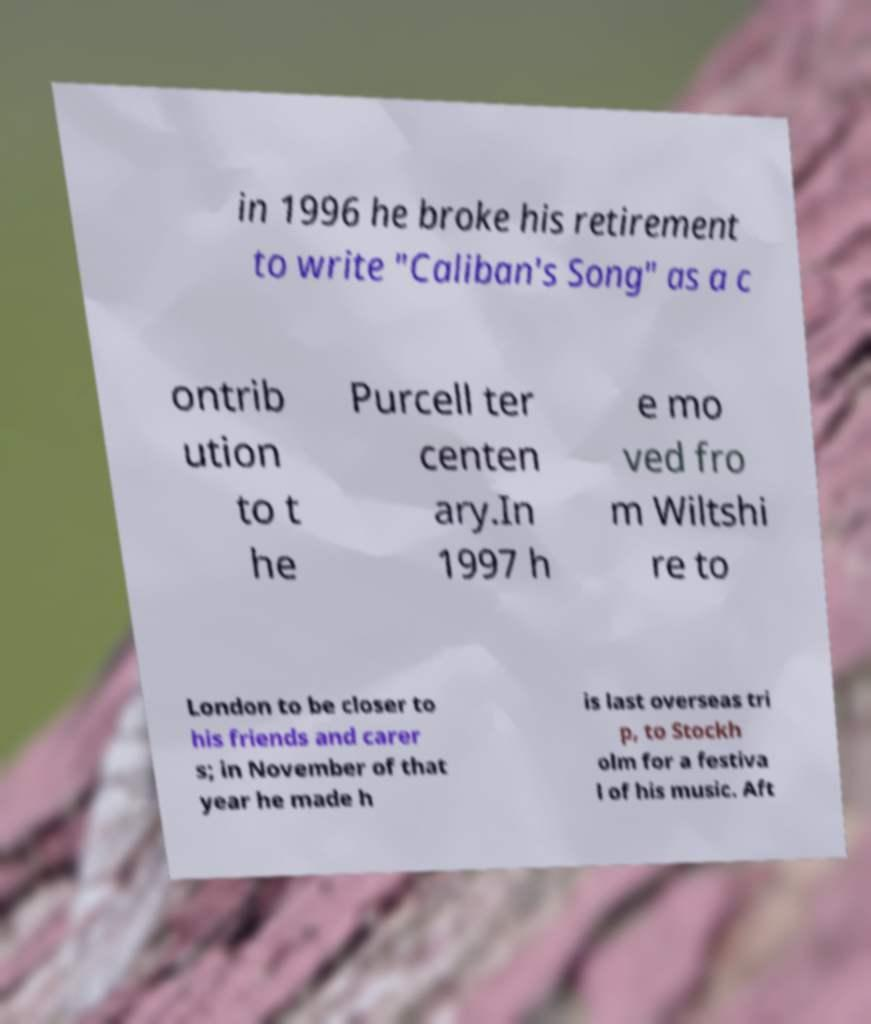Please read and relay the text visible in this image. What does it say? in 1996 he broke his retirement to write "Caliban's Song" as a c ontrib ution to t he Purcell ter centen ary.In 1997 h e mo ved fro m Wiltshi re to London to be closer to his friends and carer s; in November of that year he made h is last overseas tri p, to Stockh olm for a festiva l of his music. Aft 